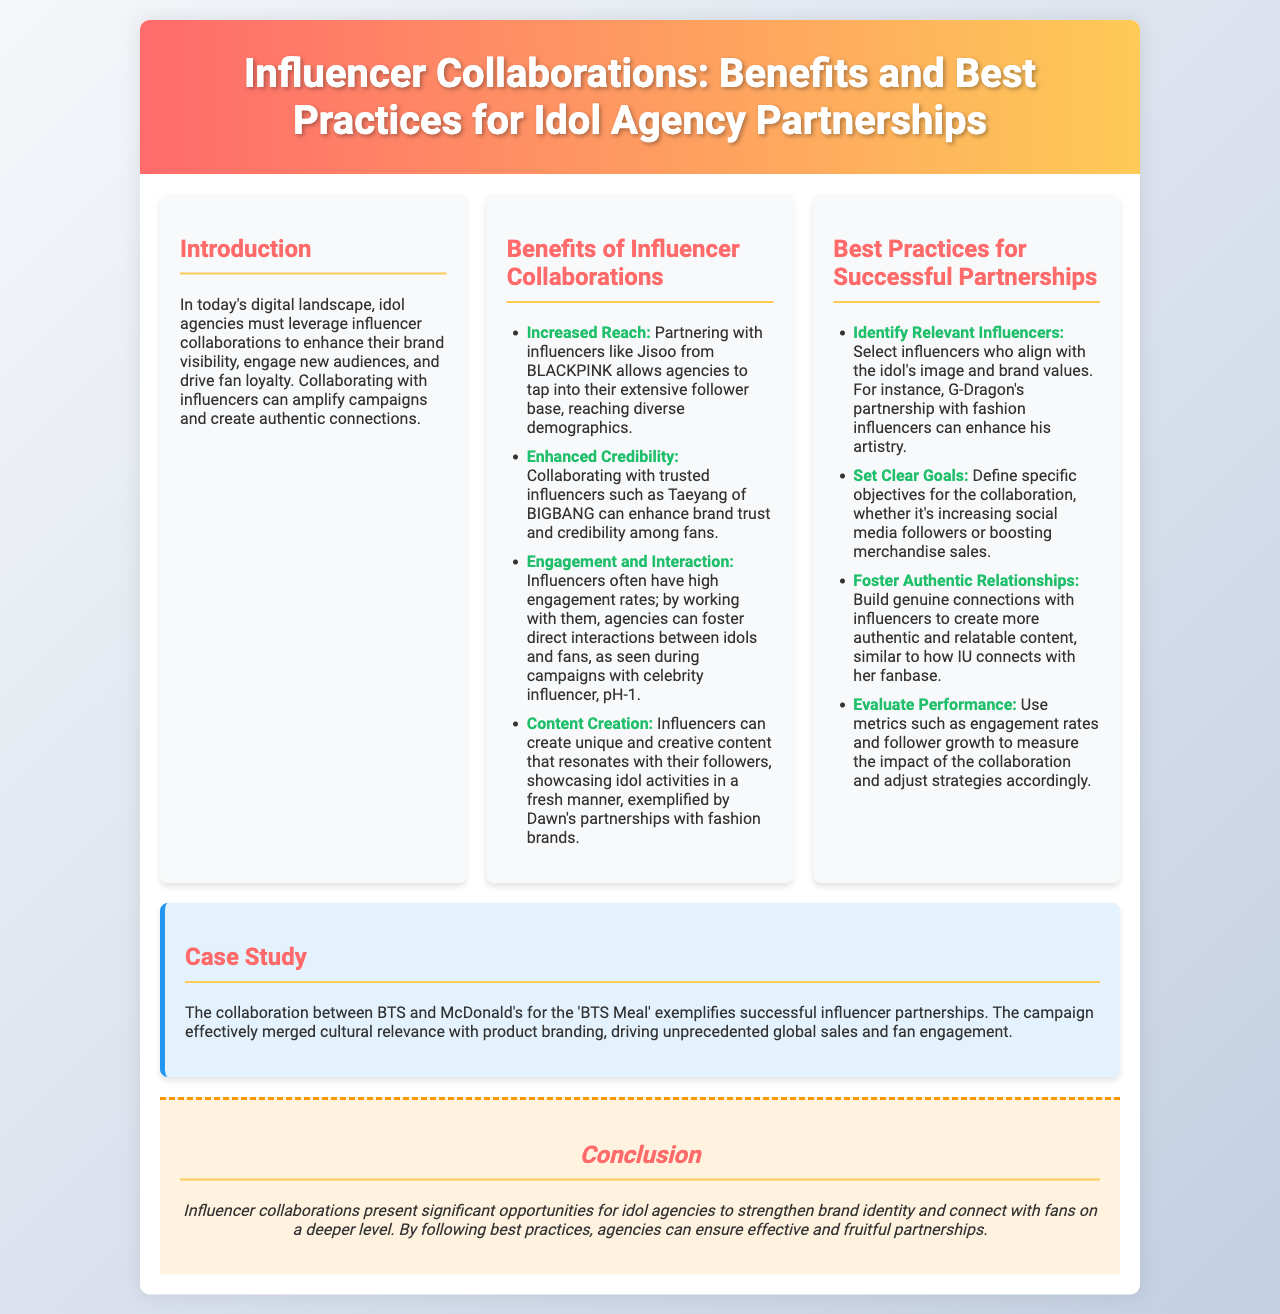What is the title of the brochure? The title appears prominently in the header section of the brochure.
Answer: Influencer Collaborations: Benefits and Best Practices for Idol Agency Partnerships Who is mentioned as an influencer with a large follower base? The document lists Jisoo from BLACKPINK as an example of an influencer with extensive followers.
Answer: Jisoo What is one benefit of influencer collaborations mentioned? The document outlines multiple benefits, one of which is stated clearly under the "Benefits of Influencer Collaborations" section.
Answer: Increased Reach What should agencies identify when selecting influencers? The best practices section emphasizes the importance of selecting influencers based on criteria that enhance partnership success.
Answer: Relevant Influencers Which case study is highlighted in the brochure? The case study section refers to a particular notable collaboration which exemplifies successful influencer partnerships.
Answer: BTS and McDonald's for the 'BTS Meal' What is a key aspect to foster in partnerships according to best practices? The document states this critical relationship aspect under the "Best Practices for Successful Partnerships" section, which is important for creating relatable content.
Answer: Authentic Relationships What color is the header of the brochure? The specific design elements of the brochure describe the color used in the header section.
Answer: Gradient of red and yellow Which influencer is associated with fashion partnerships? The brochure references a particular influencer well-known for their associations with fashion.
Answer: G-Dragon How does the brochure describe the nature of influencer content? The document specifically characterizes the type of content influencers can provide through a distinct description.
Answer: Unique and creative content 